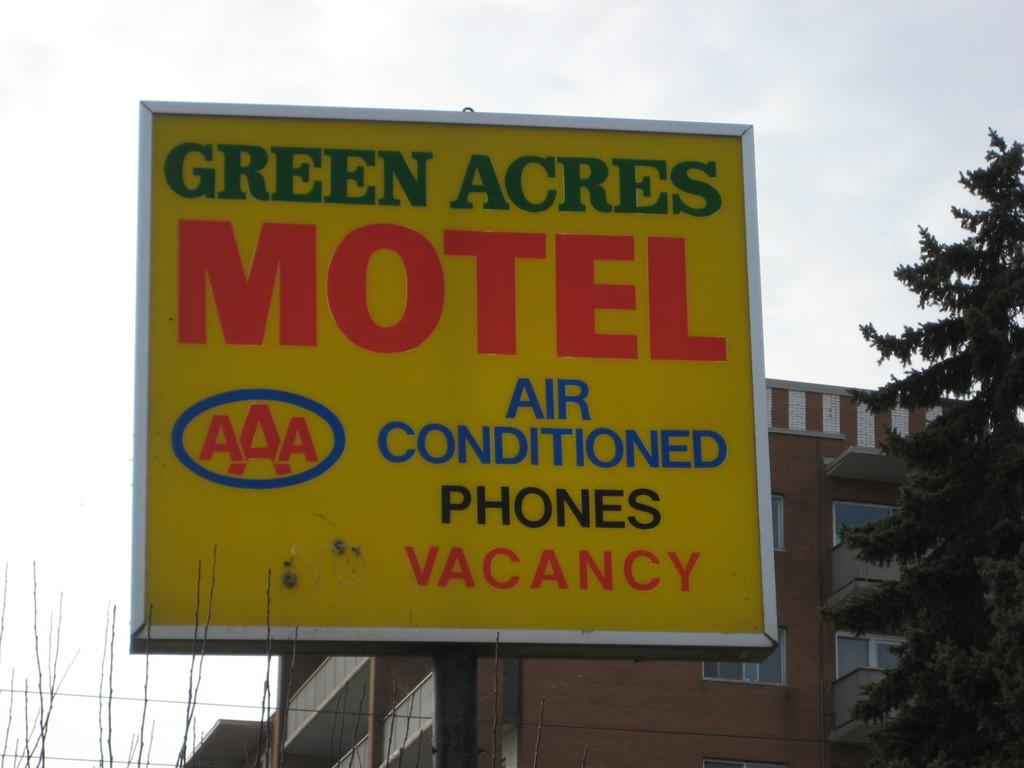What is located at the front of the image? There is a board at the front of the image. What can be seen in the background of the image? There are buildings, trees, and the sky visible in the background of the image. How many sheep are visible in the image? There are no sheep present in the image. What type of hands are holding the board in the image? There are no hands visible in the image, as the board is likely stationary. 